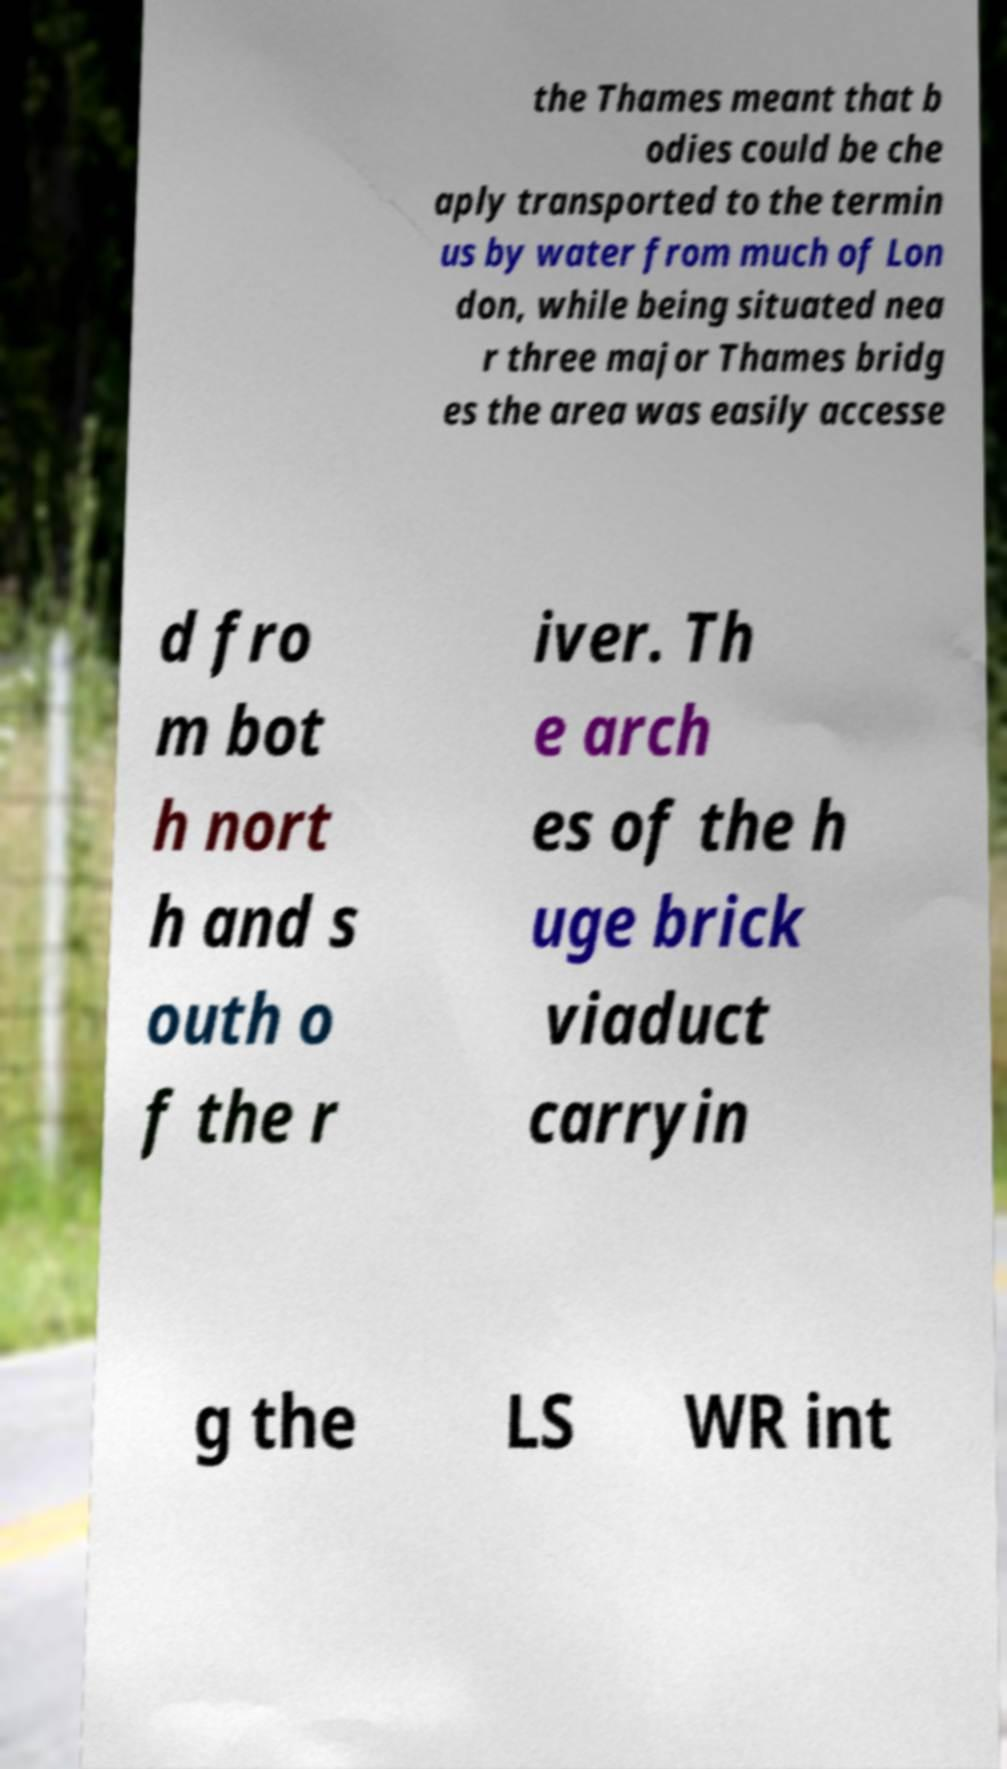Please identify and transcribe the text found in this image. the Thames meant that b odies could be che aply transported to the termin us by water from much of Lon don, while being situated nea r three major Thames bridg es the area was easily accesse d fro m bot h nort h and s outh o f the r iver. Th e arch es of the h uge brick viaduct carryin g the LS WR int 